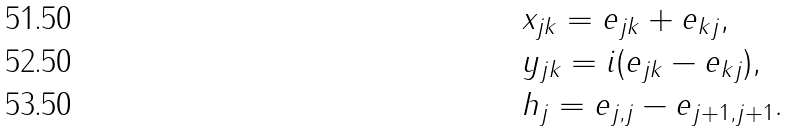<formula> <loc_0><loc_0><loc_500><loc_500>& x _ { j k } = e _ { j k } + e _ { k j } , \\ & y _ { j k } = i ( e _ { j k } - e _ { k j } ) , \\ & h _ { j } = e _ { j , j } - e _ { j + 1 , j + 1 } .</formula> 